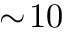<formula> <loc_0><loc_0><loc_500><loc_500>\sim \, 1 0</formula> 